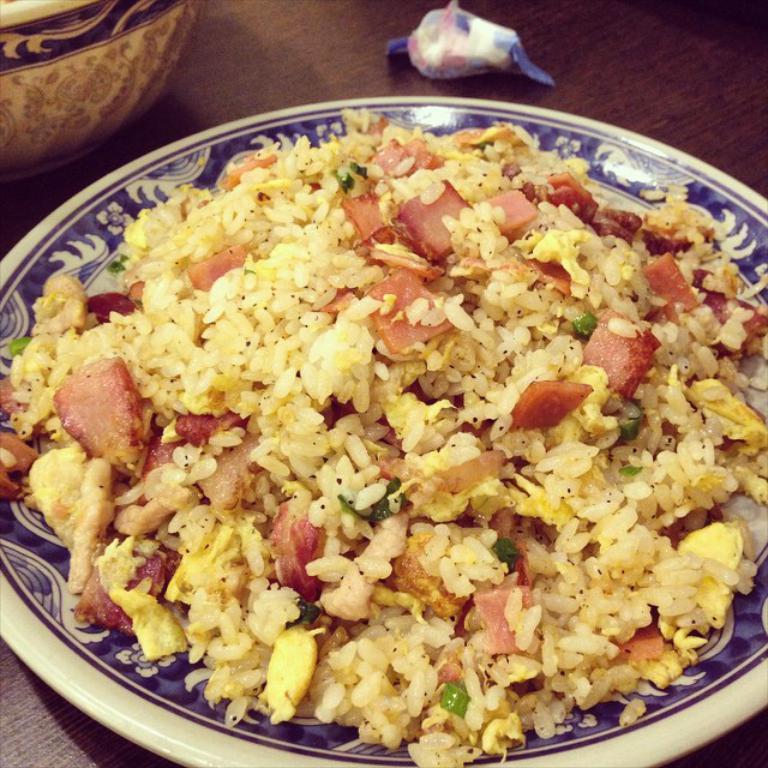Please provide a concise description of this image. In the center of the image there is a food item in a plate. There is a table. There is a bowl. 